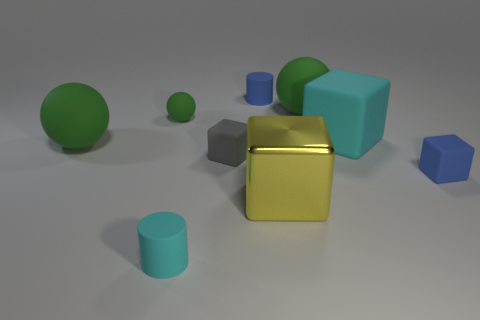How many objects are there in the image, and can you sort them by size? There are eight objects in the image, with varying geometrical shapes. If we sort them by size from largest to smallest, we have: one large cube, one large sphere, one medium-sized cylinder, two medium-sized cubes, one small sphere, one small cylinder, and finally, one tiny sphere. 